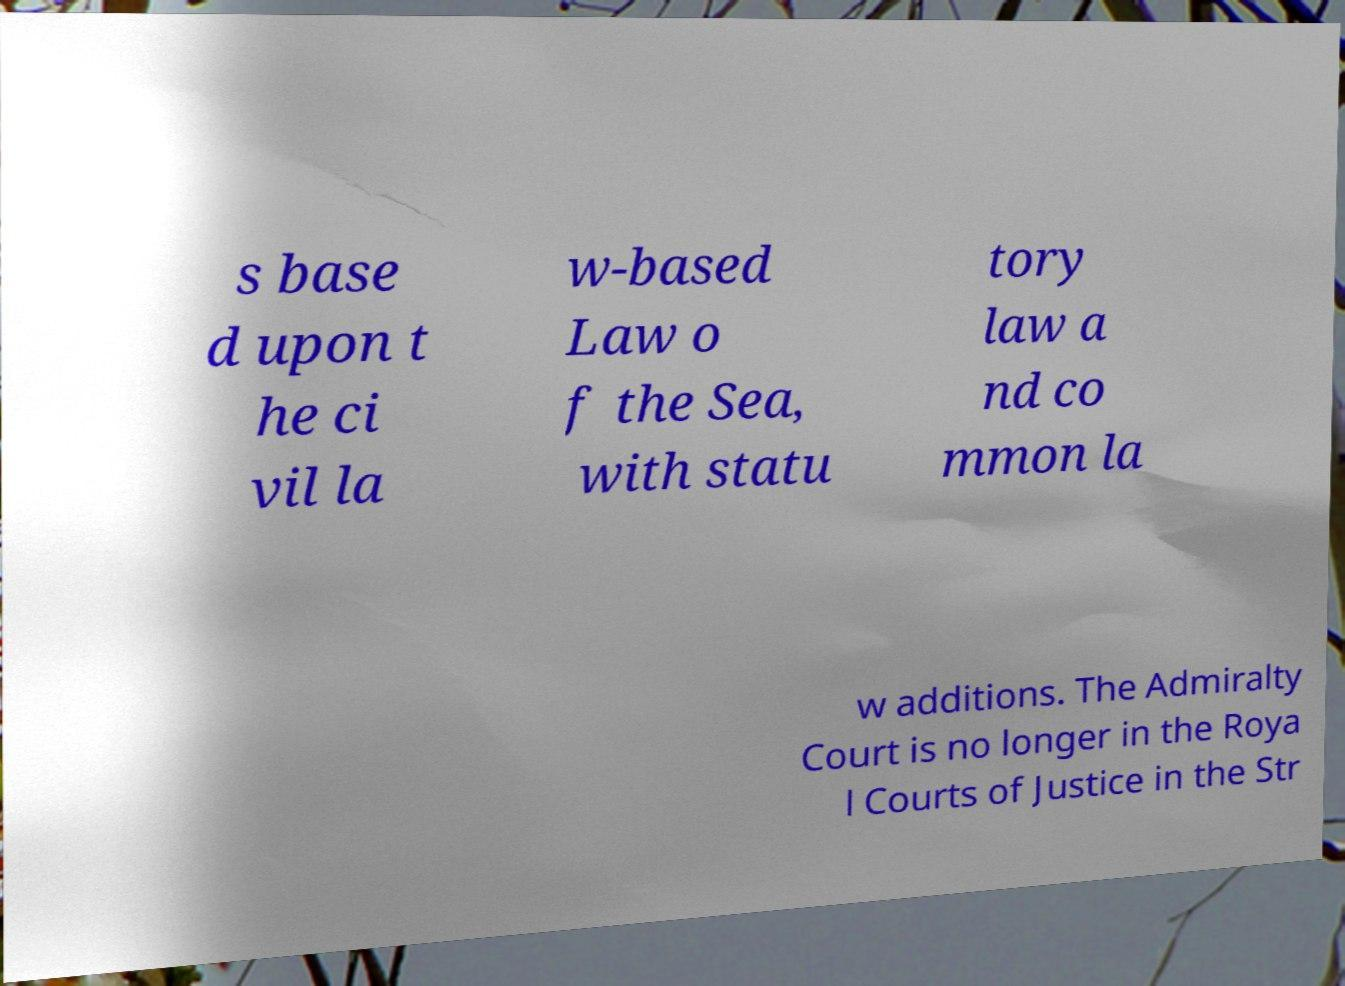Please read and relay the text visible in this image. What does it say? s base d upon t he ci vil la w-based Law o f the Sea, with statu tory law a nd co mmon la w additions. The Admiralty Court is no longer in the Roya l Courts of Justice in the Str 